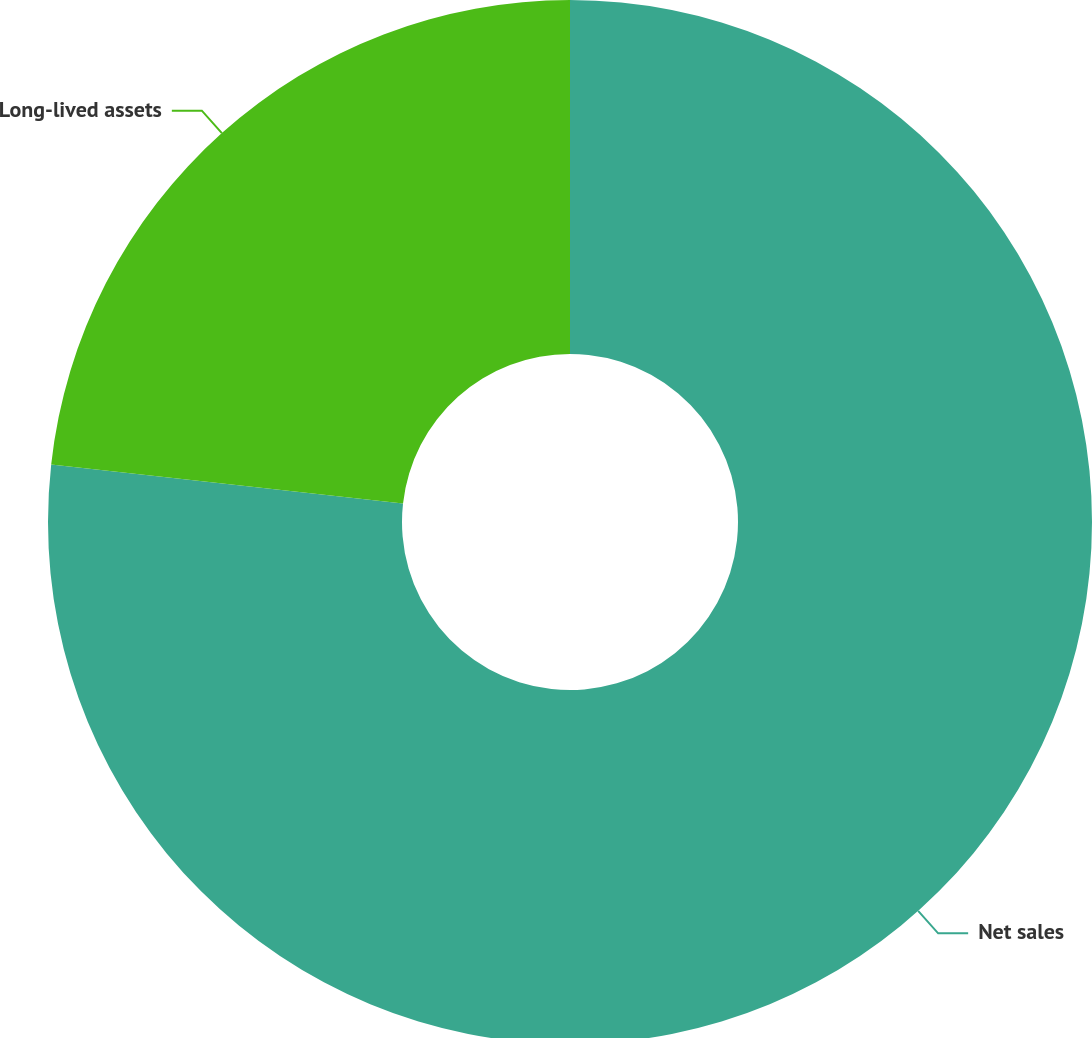Convert chart. <chart><loc_0><loc_0><loc_500><loc_500><pie_chart><fcel>Net sales<fcel>Long-lived assets<nl><fcel>76.76%<fcel>23.24%<nl></chart> 